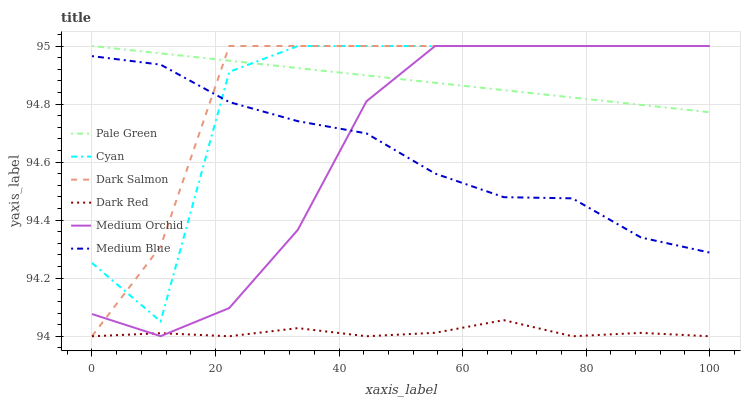Does Medium Orchid have the minimum area under the curve?
Answer yes or no. No. Does Medium Orchid have the maximum area under the curve?
Answer yes or no. No. Is Medium Orchid the smoothest?
Answer yes or no. No. Is Medium Orchid the roughest?
Answer yes or no. No. Does Medium Orchid have the lowest value?
Answer yes or no. No. Does Medium Blue have the highest value?
Answer yes or no. No. Is Dark Red less than Dark Salmon?
Answer yes or no. Yes. Is Pale Green greater than Medium Blue?
Answer yes or no. Yes. Does Dark Red intersect Dark Salmon?
Answer yes or no. No. 